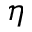<formula> <loc_0><loc_0><loc_500><loc_500>\eta</formula> 